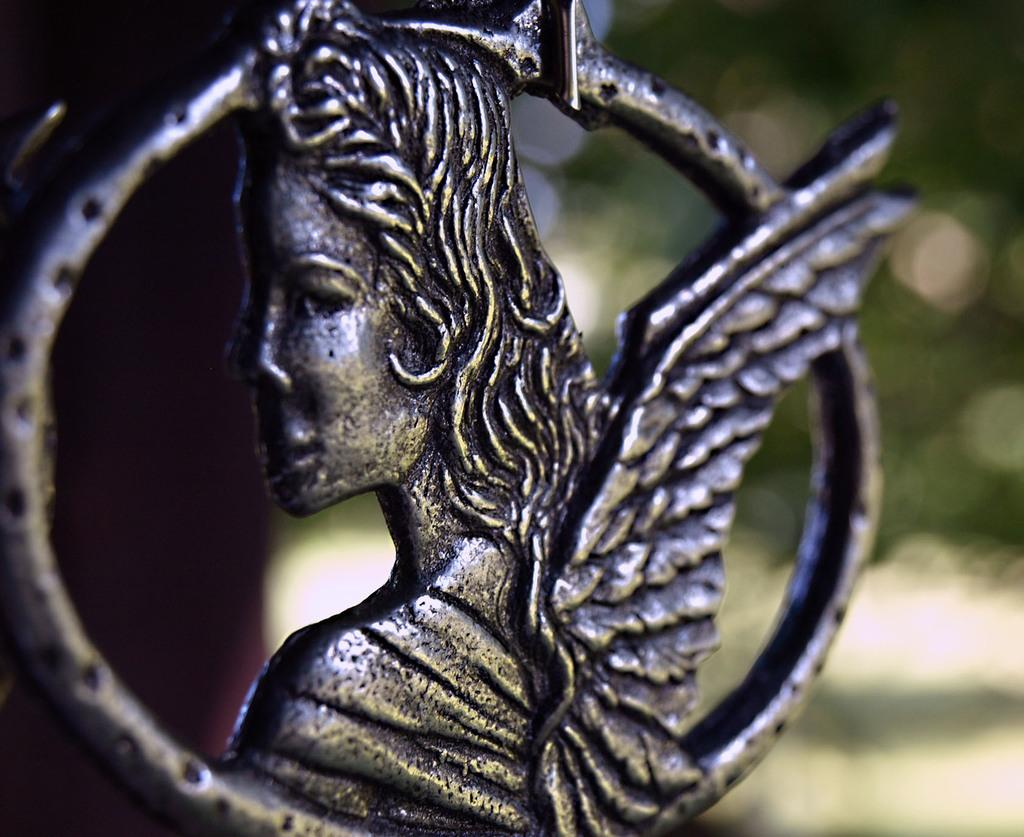What is the main subject of the image? There is a statue in the image. What type of wren is perched on the statue's shoulder in the image? There is no wren present in the image; it only features a statue. What advice does the statue's grandmother give in the image? There is no grandmother or any dialogue present in the image, as it only features a statue. 